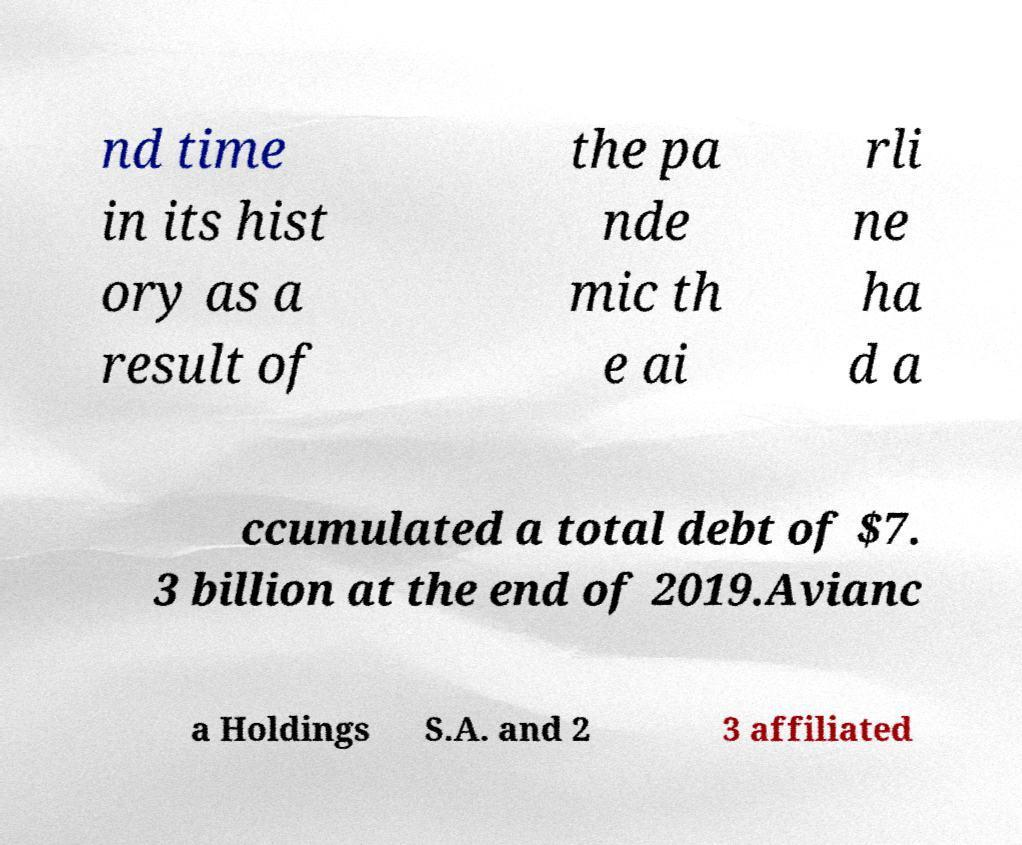Could you assist in decoding the text presented in this image and type it out clearly? nd time in its hist ory as a result of the pa nde mic th e ai rli ne ha d a ccumulated a total debt of $7. 3 billion at the end of 2019.Avianc a Holdings S.A. and 2 3 affiliated 